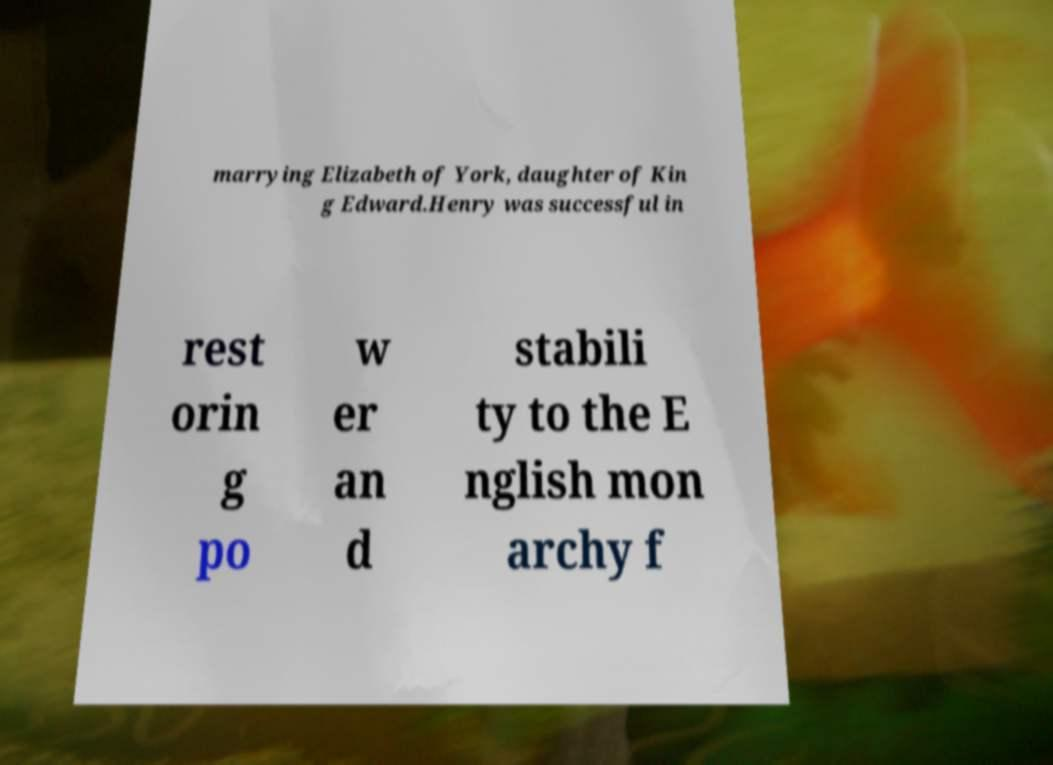Could you extract and type out the text from this image? marrying Elizabeth of York, daughter of Kin g Edward.Henry was successful in rest orin g po w er an d stabili ty to the E nglish mon archy f 